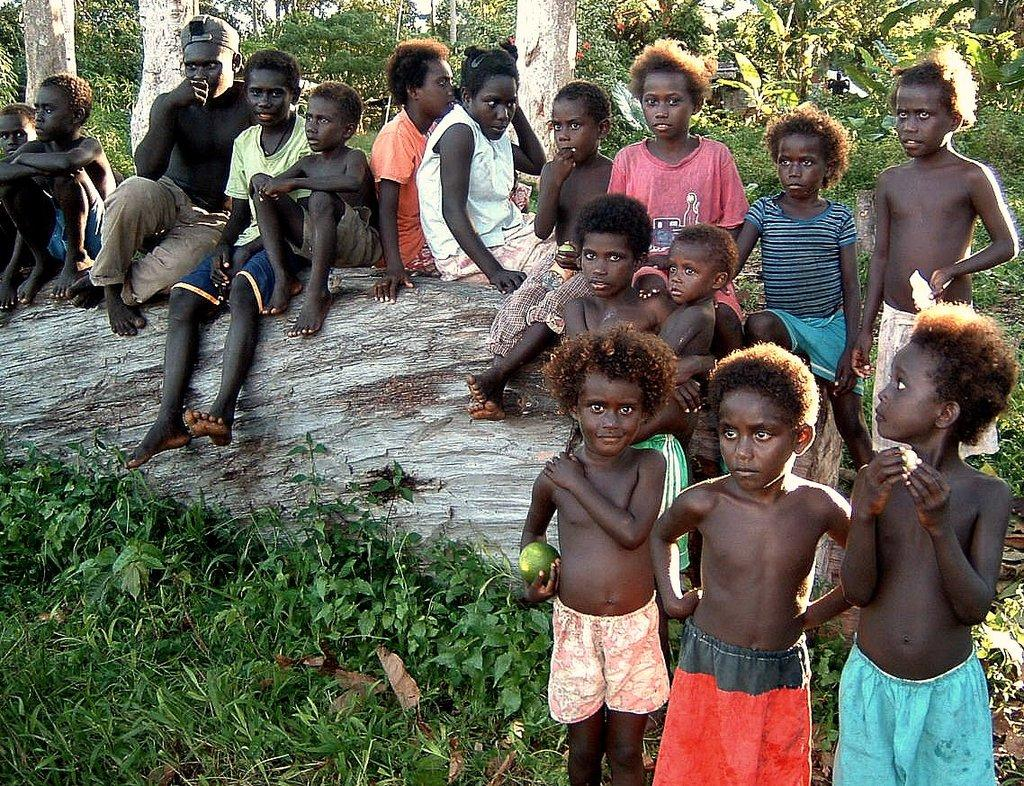How many children are present in the image? There are many kids in the image. What are the kids doing in the image? The kids are sitting and standing on the ground. What type of vegetation is present in the area? There are trees surrounding the area, and there is grass in the area. What type of wax can be seen melting on the ground in the image? There is no wax present in the image; it features kids sitting and standing on the ground surrounded by trees and grass. 